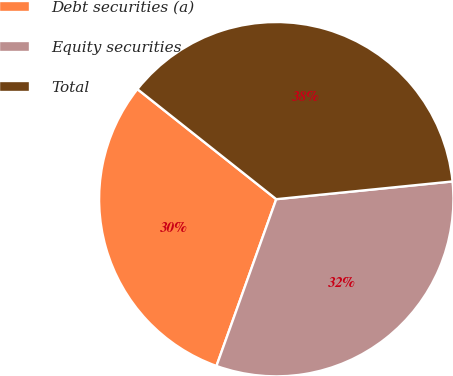Convert chart to OTSL. <chart><loc_0><loc_0><loc_500><loc_500><pie_chart><fcel>Debt securities (a)<fcel>Equity securities<fcel>Total<nl><fcel>30.19%<fcel>32.08%<fcel>37.74%<nl></chart> 